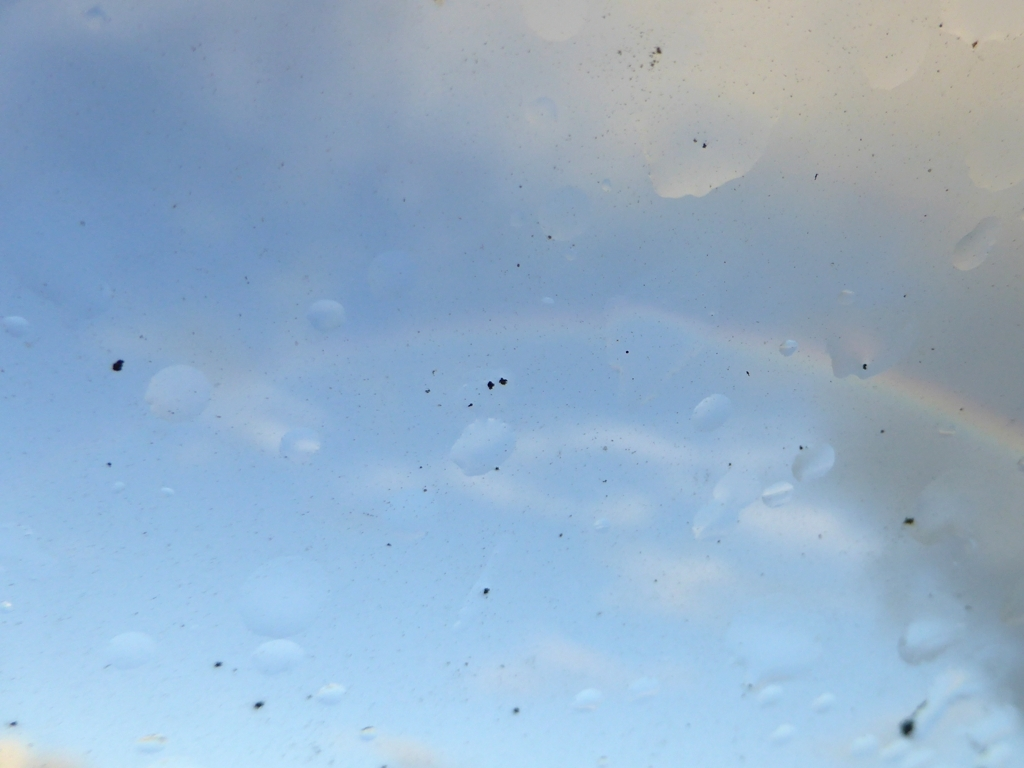Can you tell what is causing the blurry effect in this image? The blurry effect seems to be caused by droplets on the surface through which the photo was taken, possibly a window, creating a smudge-like appearance and scattering the light. Is there anything in the image that stands out to you? Despite the lack of clarity, a faint rainbow is visible, which adds a touch of color and suggests the sun might be reflecting off moisture in the air. 